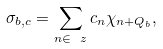Convert formula to latex. <formula><loc_0><loc_0><loc_500><loc_500>\sigma _ { b , { c } } = \sum _ { n \in \ z } c _ { n } \chi _ { n + Q _ { b } } ,</formula> 